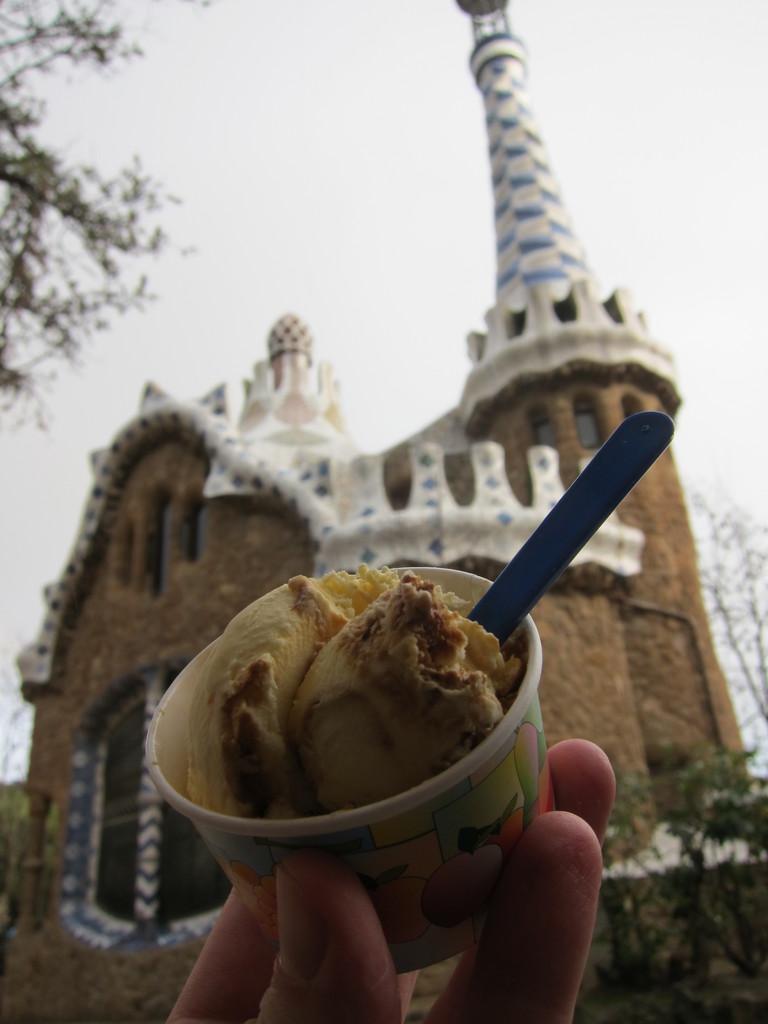Can you describe this image briefly? In this image there is a cup of ice cream with a spoon in the middle. In the background there is a castle. On the left side top there is a tree. At the bottom there are fingers which are holding the cup. 